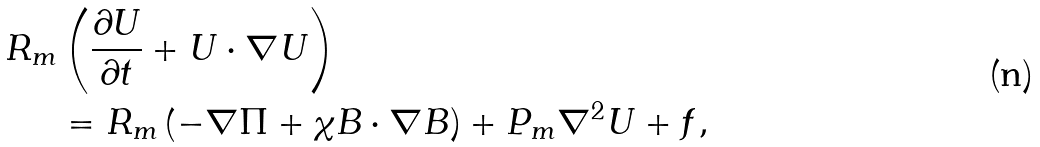<formula> <loc_0><loc_0><loc_500><loc_500>R _ { m } & \left ( \frac { \partial U } { \partial t } + U \cdot \nabla U \right ) \\ & = R _ { m } \left ( - \nabla \Pi + \chi B \cdot \nabla B \right ) + P _ { m } \nabla ^ { 2 } U + f ,</formula> 